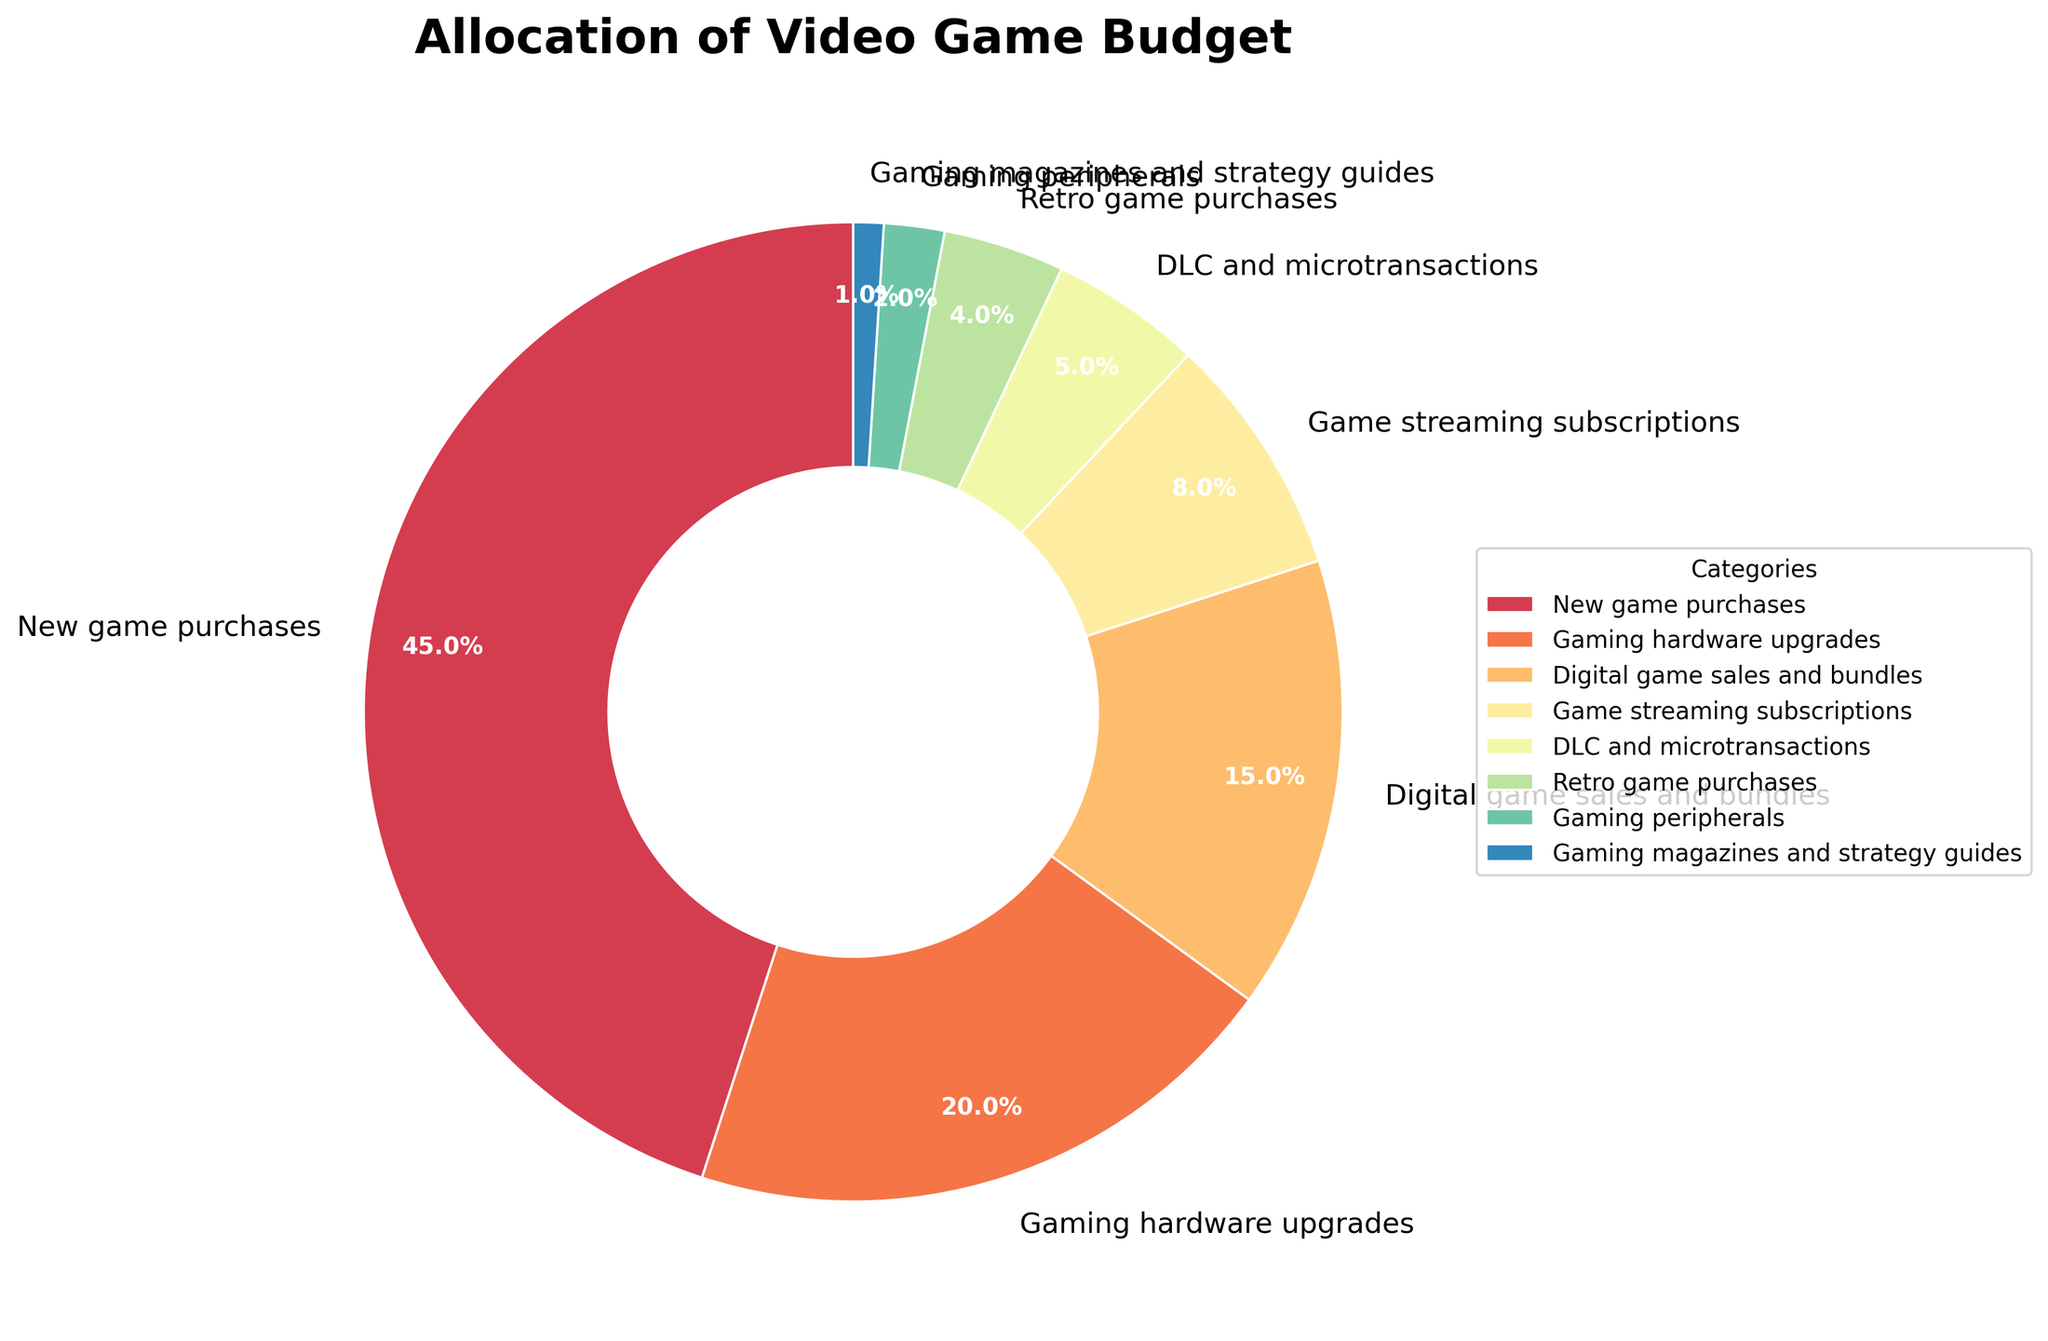what is the percentage allocation for gaming hardware upgrades and digital game sales and bundles together? To find the total percentage allocation for gaming hardware upgrades and digital game sales and bundles, you need to add the percentages from both categories. Gaming hardware upgrades have an allocation of 20%, and digital game sales and bundles have 15%. So, 20% + 15% = 35%.
Answer: 35% Which category has the lowest percentage allocation, and what is that percentage? The category with the lowest percentage allocation is "Gaming magazines and strategy guides," which has an allocation of 1%.
Answer: Gaming magazines and strategy guides, 1% What is the difference between the percentage allocations of new game purchases and gaming peripherals? To find the difference, you subtract the smaller percentage from the larger one. New game purchases have an allocation of 45%, and gaming peripherals have 2%. The difference is 45% - 2% = 43%.
Answer: 43% Which category has a higher percentage allocation: game streaming subscriptions or DLC and microtransactions? Game streaming subscriptions have an allocation of 8%, while DLC and microtransactions have 5%. Since 8% > 5%, game streaming subscriptions have a higher percentage allocation.
Answer: Game streaming subscriptions What percentage of the budget is allocated to categories with less than 10% each? The categories with less than 10% each are game streaming subscriptions (8%), DLC and microtransactions (5%), retro game purchases (4%), gaming peripherals (2%), and gaming magazines and strategy guides (1%). To find the total, add these percentages: 8% + 5% + 4% + 2% + 1% = 20%.
Answer: 20% Is the percentage allocation for digital game sales and bundles greater than, less than, or equal to the combined percentage allocations for retro game purchases and gaming peripherals? To compare, calculate the combined percentage for retro game purchases and gaming peripherals, which are 4% and 2%, respectively. So, 4% + 2% = 6%. Since digital game sales and bundles have an allocation of 15%, which is greater than 6%, they are greater.
Answer: Greater How does the percentage allocation for new game purchases compare to the combined allocation of gaming hardware upgrades and game streaming subscriptions? First, add the percentages for gaming hardware upgrades (20%) and game streaming subscriptions (8%): 20% + 8% = 28%. New game purchases have an allocation of 45%. Since 45% > 28%, new game purchases have a higher percentage allocation.
Answer: Higher Which category is represented with the largest wedge in the pie chart, and what is its percentage? The category with the largest wedge is "New game purchases" with a percentage allocation of 45%.
Answer: New game purchases, 45% How much larger is the percentage allocation for new game purchases compared to the percentage allocation for game streaming subscriptions? New game purchases have an allocation of 45%, while game streaming subscriptions have 8%. The difference is 45% - 8% = 37%.
Answer: 37% What is the combined percentage allocation of categories that are allocated less than 5% each? The categories with less than 5% allocation are retro game purchases (4%), gaming peripherals (2%), and gaming magazines and strategy guides (1%). Adding them together: 4% + 2% + 1% = 7%.
Answer: 7% 